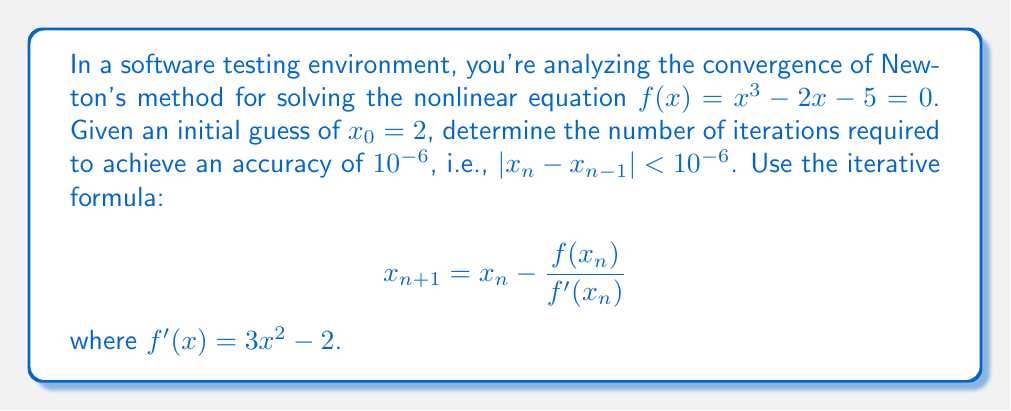Teach me how to tackle this problem. To solve this problem, we'll follow these steps:

1) First, let's implement Newton's method:
   $$ x_{n+1} = x_n - \frac{f(x_n)}{f'(x_n)} = x_n - \frac{x_n^3 - 2x_n - 5}{3x_n^2 - 2} $$

2) We'll iterate until $|x_n - x_{n-1}| < 10^{-6}$. Let's start with $x_0 = 2$:

   Iteration 1:
   $x_1 = 2 - \frac{2^3 - 2(2) - 5}{3(2)^2 - 2} = 2 - \frac{-1}{10} = 2.1$
   $|x_1 - x_0| = |2.1 - 2| = 0.1 > 10^{-6}$

   Iteration 2:
   $x_2 = 2.1 - \frac{2.1^3 - 2(2.1) - 5}{3(2.1)^2 - 2} \approx 2.09455148$
   $|x_2 - x_1| \approx 0.00544852 > 10^{-6}$

   Iteration 3:
   $x_3 \approx 2.09455147983439$
   $|x_3 - x_2| \approx 1.64561 \times 10^{-8} < 10^{-6}$

3) We see that after 3 iterations, we've achieved the desired accuracy.

This rapid convergence is typical for Newton's method when the initial guess is close to the root and when the function is well-behaved near the root.
Answer: 3 iterations 